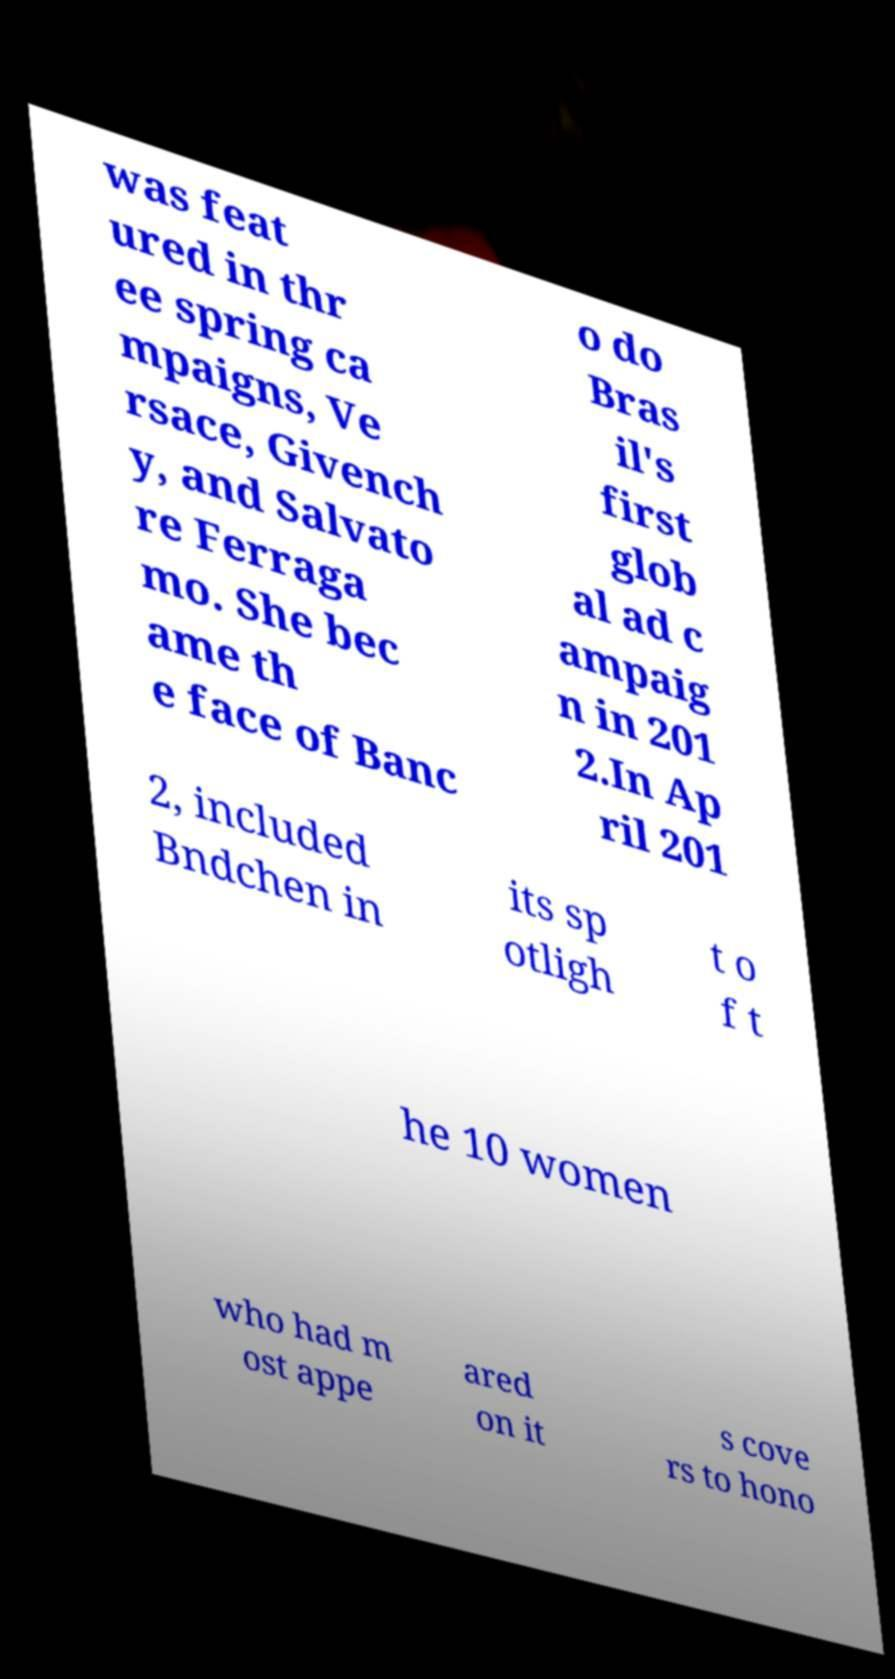Please read and relay the text visible in this image. What does it say? was feat ured in thr ee spring ca mpaigns, Ve rsace, Givench y, and Salvato re Ferraga mo. She bec ame th e face of Banc o do Bras il's first glob al ad c ampaig n in 201 2.In Ap ril 201 2, included Bndchen in its sp otligh t o f t he 10 women who had m ost appe ared on it s cove rs to hono 